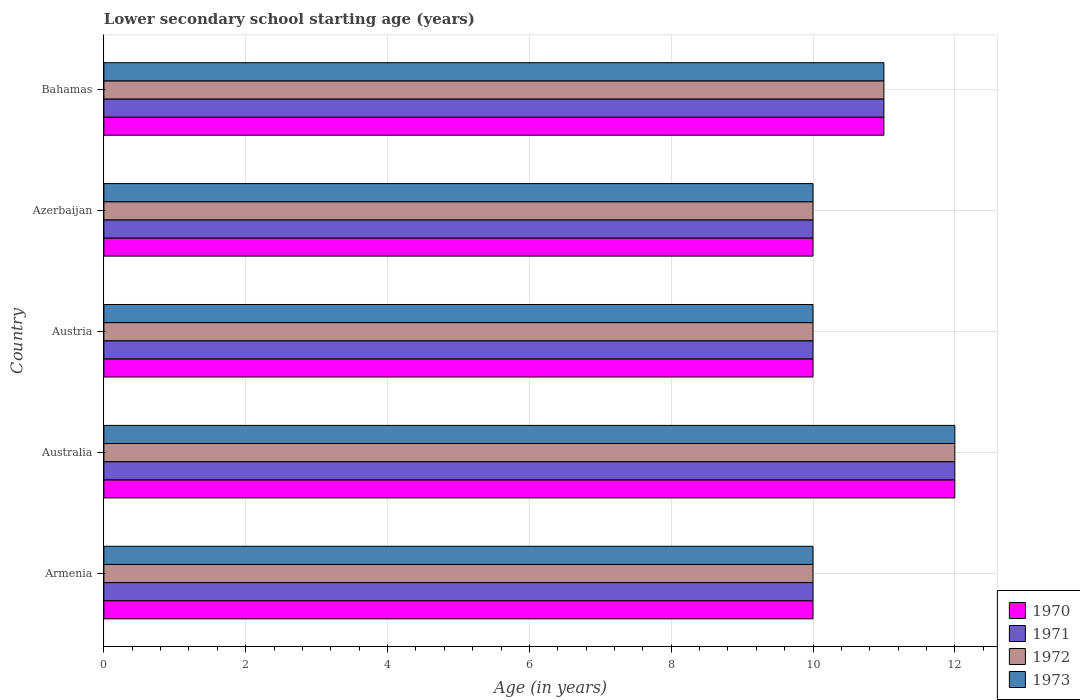How many different coloured bars are there?
Provide a succinct answer. 4. Are the number of bars on each tick of the Y-axis equal?
Make the answer very short. Yes. How many bars are there on the 2nd tick from the top?
Give a very brief answer. 4. How many bars are there on the 3rd tick from the bottom?
Provide a succinct answer. 4. In how many cases, is the number of bars for a given country not equal to the number of legend labels?
Provide a succinct answer. 0. What is the lower secondary school starting age of children in 1972 in Bahamas?
Provide a succinct answer. 11. In which country was the lower secondary school starting age of children in 1973 minimum?
Make the answer very short. Armenia. What is the total lower secondary school starting age of children in 1971 in the graph?
Your answer should be very brief. 53. What is the difference between the lower secondary school starting age of children in 1972 in Australia and that in Azerbaijan?
Keep it short and to the point. 2. What is the difference between the lower secondary school starting age of children in 1973 and lower secondary school starting age of children in 1970 in Austria?
Make the answer very short. 0. In how many countries, is the lower secondary school starting age of children in 1970 greater than 8.8 years?
Your answer should be compact. 5. What is the ratio of the lower secondary school starting age of children in 1972 in Azerbaijan to that in Bahamas?
Offer a very short reply. 0.91. Is the lower secondary school starting age of children in 1970 in Armenia less than that in Austria?
Give a very brief answer. No. Is the difference between the lower secondary school starting age of children in 1973 in Azerbaijan and Bahamas greater than the difference between the lower secondary school starting age of children in 1970 in Azerbaijan and Bahamas?
Offer a very short reply. No. What does the 3rd bar from the top in Armenia represents?
Offer a very short reply. 1971. What does the 3rd bar from the bottom in Bahamas represents?
Give a very brief answer. 1972. How many bars are there?
Your answer should be compact. 20. Are all the bars in the graph horizontal?
Your response must be concise. Yes. How many countries are there in the graph?
Give a very brief answer. 5. Are the values on the major ticks of X-axis written in scientific E-notation?
Make the answer very short. No. Does the graph contain grids?
Your answer should be very brief. Yes. How are the legend labels stacked?
Provide a short and direct response. Vertical. What is the title of the graph?
Give a very brief answer. Lower secondary school starting age (years). Does "1989" appear as one of the legend labels in the graph?
Offer a terse response. No. What is the label or title of the X-axis?
Keep it short and to the point. Age (in years). What is the Age (in years) of 1970 in Armenia?
Ensure brevity in your answer.  10. What is the Age (in years) of 1971 in Armenia?
Provide a succinct answer. 10. What is the Age (in years) of 1972 in Armenia?
Keep it short and to the point. 10. What is the Age (in years) of 1970 in Austria?
Keep it short and to the point. 10. What is the Age (in years) of 1972 in Austria?
Offer a terse response. 10. What is the Age (in years) of 1973 in Austria?
Provide a succinct answer. 10. What is the Age (in years) in 1972 in Azerbaijan?
Provide a short and direct response. 10. What is the Age (in years) of 1970 in Bahamas?
Your answer should be compact. 11. What is the Age (in years) of 1971 in Bahamas?
Provide a succinct answer. 11. What is the Age (in years) of 1973 in Bahamas?
Offer a very short reply. 11. Across all countries, what is the maximum Age (in years) of 1970?
Offer a terse response. 12. Across all countries, what is the maximum Age (in years) in 1971?
Ensure brevity in your answer.  12. Across all countries, what is the maximum Age (in years) in 1973?
Make the answer very short. 12. Across all countries, what is the minimum Age (in years) of 1972?
Your response must be concise. 10. What is the total Age (in years) of 1971 in the graph?
Offer a terse response. 53. What is the total Age (in years) of 1972 in the graph?
Your response must be concise. 53. What is the total Age (in years) in 1973 in the graph?
Ensure brevity in your answer.  53. What is the difference between the Age (in years) in 1972 in Armenia and that in Australia?
Your answer should be compact. -2. What is the difference between the Age (in years) of 1973 in Armenia and that in Australia?
Give a very brief answer. -2. What is the difference between the Age (in years) in 1970 in Armenia and that in Austria?
Your response must be concise. 0. What is the difference between the Age (in years) in 1972 in Armenia and that in Austria?
Offer a very short reply. 0. What is the difference between the Age (in years) in 1971 in Armenia and that in Azerbaijan?
Your response must be concise. 0. What is the difference between the Age (in years) in 1972 in Armenia and that in Bahamas?
Your answer should be very brief. -1. What is the difference between the Age (in years) of 1970 in Australia and that in Austria?
Your answer should be compact. 2. What is the difference between the Age (in years) in 1971 in Australia and that in Austria?
Keep it short and to the point. 2. What is the difference between the Age (in years) in 1972 in Australia and that in Austria?
Your response must be concise. 2. What is the difference between the Age (in years) in 1973 in Australia and that in Austria?
Make the answer very short. 2. What is the difference between the Age (in years) in 1970 in Australia and that in Bahamas?
Give a very brief answer. 1. What is the difference between the Age (in years) in 1973 in Australia and that in Bahamas?
Your answer should be very brief. 1. What is the difference between the Age (in years) of 1972 in Austria and that in Azerbaijan?
Offer a very short reply. 0. What is the difference between the Age (in years) of 1970 in Austria and that in Bahamas?
Offer a very short reply. -1. What is the difference between the Age (in years) of 1972 in Austria and that in Bahamas?
Offer a terse response. -1. What is the difference between the Age (in years) in 1973 in Austria and that in Bahamas?
Your answer should be compact. -1. What is the difference between the Age (in years) of 1970 in Azerbaijan and that in Bahamas?
Provide a succinct answer. -1. What is the difference between the Age (in years) of 1971 in Azerbaijan and that in Bahamas?
Provide a short and direct response. -1. What is the difference between the Age (in years) in 1972 in Azerbaijan and that in Bahamas?
Your answer should be compact. -1. What is the difference between the Age (in years) of 1971 in Armenia and the Age (in years) of 1972 in Australia?
Provide a short and direct response. -2. What is the difference between the Age (in years) in 1971 in Armenia and the Age (in years) in 1973 in Australia?
Offer a very short reply. -2. What is the difference between the Age (in years) in 1972 in Armenia and the Age (in years) in 1973 in Australia?
Ensure brevity in your answer.  -2. What is the difference between the Age (in years) of 1971 in Armenia and the Age (in years) of 1972 in Austria?
Make the answer very short. 0. What is the difference between the Age (in years) of 1970 in Armenia and the Age (in years) of 1973 in Azerbaijan?
Provide a succinct answer. 0. What is the difference between the Age (in years) in 1972 in Armenia and the Age (in years) in 1973 in Azerbaijan?
Keep it short and to the point. 0. What is the difference between the Age (in years) in 1970 in Armenia and the Age (in years) in 1971 in Bahamas?
Provide a short and direct response. -1. What is the difference between the Age (in years) of 1971 in Armenia and the Age (in years) of 1973 in Bahamas?
Provide a short and direct response. -1. What is the difference between the Age (in years) of 1972 in Armenia and the Age (in years) of 1973 in Bahamas?
Offer a very short reply. -1. What is the difference between the Age (in years) in 1970 in Australia and the Age (in years) in 1973 in Austria?
Your answer should be very brief. 2. What is the difference between the Age (in years) in 1971 in Australia and the Age (in years) in 1973 in Austria?
Offer a terse response. 2. What is the difference between the Age (in years) in 1972 in Australia and the Age (in years) in 1973 in Austria?
Provide a succinct answer. 2. What is the difference between the Age (in years) in 1971 in Australia and the Age (in years) in 1972 in Azerbaijan?
Your response must be concise. 2. What is the difference between the Age (in years) of 1971 in Australia and the Age (in years) of 1973 in Azerbaijan?
Ensure brevity in your answer.  2. What is the difference between the Age (in years) of 1970 in Australia and the Age (in years) of 1971 in Bahamas?
Offer a very short reply. 1. What is the difference between the Age (in years) in 1970 in Australia and the Age (in years) in 1973 in Bahamas?
Your answer should be compact. 1. What is the difference between the Age (in years) in 1971 in Australia and the Age (in years) in 1972 in Bahamas?
Your answer should be compact. 1. What is the difference between the Age (in years) of 1971 in Australia and the Age (in years) of 1973 in Bahamas?
Give a very brief answer. 1. What is the difference between the Age (in years) of 1972 in Australia and the Age (in years) of 1973 in Bahamas?
Give a very brief answer. 1. What is the difference between the Age (in years) of 1970 in Austria and the Age (in years) of 1972 in Azerbaijan?
Keep it short and to the point. 0. What is the difference between the Age (in years) of 1970 in Austria and the Age (in years) of 1973 in Azerbaijan?
Make the answer very short. 0. What is the difference between the Age (in years) in 1971 in Austria and the Age (in years) in 1973 in Azerbaijan?
Give a very brief answer. 0. What is the difference between the Age (in years) of 1970 in Austria and the Age (in years) of 1972 in Bahamas?
Provide a succinct answer. -1. What is the difference between the Age (in years) in 1970 in Austria and the Age (in years) in 1973 in Bahamas?
Your answer should be very brief. -1. What is the difference between the Age (in years) in 1971 in Austria and the Age (in years) in 1973 in Bahamas?
Keep it short and to the point. -1. What is the difference between the Age (in years) in 1972 in Austria and the Age (in years) in 1973 in Bahamas?
Give a very brief answer. -1. What is the difference between the Age (in years) in 1970 in Azerbaijan and the Age (in years) in 1971 in Bahamas?
Keep it short and to the point. -1. What is the difference between the Age (in years) of 1970 in Azerbaijan and the Age (in years) of 1973 in Bahamas?
Provide a short and direct response. -1. What is the difference between the Age (in years) of 1971 in Azerbaijan and the Age (in years) of 1972 in Bahamas?
Your response must be concise. -1. What is the average Age (in years) of 1971 per country?
Your response must be concise. 10.6. What is the average Age (in years) of 1972 per country?
Your answer should be very brief. 10.6. What is the average Age (in years) in 1973 per country?
Ensure brevity in your answer.  10.6. What is the difference between the Age (in years) of 1970 and Age (in years) of 1971 in Armenia?
Keep it short and to the point. 0. What is the difference between the Age (in years) of 1971 and Age (in years) of 1973 in Armenia?
Your response must be concise. 0. What is the difference between the Age (in years) in 1970 and Age (in years) in 1971 in Australia?
Give a very brief answer. 0. What is the difference between the Age (in years) of 1971 and Age (in years) of 1972 in Australia?
Give a very brief answer. 0. What is the difference between the Age (in years) of 1972 and Age (in years) of 1973 in Australia?
Provide a succinct answer. 0. What is the difference between the Age (in years) in 1970 and Age (in years) in 1972 in Austria?
Provide a succinct answer. 0. What is the difference between the Age (in years) in 1970 and Age (in years) in 1973 in Austria?
Give a very brief answer. 0. What is the difference between the Age (in years) in 1971 and Age (in years) in 1972 in Austria?
Your answer should be compact. 0. What is the difference between the Age (in years) in 1972 and Age (in years) in 1973 in Austria?
Your answer should be compact. 0. What is the difference between the Age (in years) in 1970 and Age (in years) in 1972 in Azerbaijan?
Give a very brief answer. 0. What is the difference between the Age (in years) of 1971 and Age (in years) of 1972 in Azerbaijan?
Give a very brief answer. 0. What is the difference between the Age (in years) in 1971 and Age (in years) in 1973 in Azerbaijan?
Make the answer very short. 0. What is the difference between the Age (in years) in 1970 and Age (in years) in 1971 in Bahamas?
Your response must be concise. 0. What is the difference between the Age (in years) in 1971 and Age (in years) in 1972 in Bahamas?
Provide a short and direct response. 0. What is the difference between the Age (in years) in 1971 and Age (in years) in 1973 in Bahamas?
Keep it short and to the point. 0. What is the ratio of the Age (in years) of 1970 in Armenia to that in Australia?
Offer a terse response. 0.83. What is the ratio of the Age (in years) of 1971 in Armenia to that in Australia?
Offer a very short reply. 0.83. What is the ratio of the Age (in years) of 1973 in Armenia to that in Australia?
Make the answer very short. 0.83. What is the ratio of the Age (in years) of 1970 in Armenia to that in Austria?
Give a very brief answer. 1. What is the ratio of the Age (in years) in 1972 in Armenia to that in Austria?
Offer a terse response. 1. What is the ratio of the Age (in years) in 1973 in Armenia to that in Austria?
Your response must be concise. 1. What is the ratio of the Age (in years) in 1971 in Armenia to that in Azerbaijan?
Provide a short and direct response. 1. What is the ratio of the Age (in years) of 1970 in Armenia to that in Bahamas?
Offer a terse response. 0.91. What is the ratio of the Age (in years) in 1971 in Armenia to that in Bahamas?
Keep it short and to the point. 0.91. What is the ratio of the Age (in years) in 1973 in Armenia to that in Bahamas?
Ensure brevity in your answer.  0.91. What is the ratio of the Age (in years) in 1970 in Australia to that in Austria?
Provide a short and direct response. 1.2. What is the ratio of the Age (in years) in 1971 in Australia to that in Austria?
Your answer should be very brief. 1.2. What is the ratio of the Age (in years) in 1970 in Australia to that in Azerbaijan?
Provide a succinct answer. 1.2. What is the ratio of the Age (in years) in 1971 in Australia to that in Bahamas?
Give a very brief answer. 1.09. What is the ratio of the Age (in years) of 1972 in Australia to that in Bahamas?
Your response must be concise. 1.09. What is the ratio of the Age (in years) in 1973 in Australia to that in Bahamas?
Your response must be concise. 1.09. What is the ratio of the Age (in years) in 1972 in Austria to that in Azerbaijan?
Your answer should be very brief. 1. What is the ratio of the Age (in years) of 1970 in Austria to that in Bahamas?
Offer a terse response. 0.91. What is the ratio of the Age (in years) of 1973 in Austria to that in Bahamas?
Provide a succinct answer. 0.91. What is the ratio of the Age (in years) of 1971 in Azerbaijan to that in Bahamas?
Give a very brief answer. 0.91. What is the ratio of the Age (in years) in 1972 in Azerbaijan to that in Bahamas?
Make the answer very short. 0.91. What is the ratio of the Age (in years) of 1973 in Azerbaijan to that in Bahamas?
Ensure brevity in your answer.  0.91. What is the difference between the highest and the second highest Age (in years) in 1970?
Your response must be concise. 1. What is the difference between the highest and the second highest Age (in years) in 1972?
Give a very brief answer. 1. What is the difference between the highest and the second highest Age (in years) in 1973?
Your answer should be compact. 1. What is the difference between the highest and the lowest Age (in years) of 1970?
Your answer should be very brief. 2. What is the difference between the highest and the lowest Age (in years) of 1971?
Your answer should be very brief. 2. What is the difference between the highest and the lowest Age (in years) of 1972?
Offer a terse response. 2. 